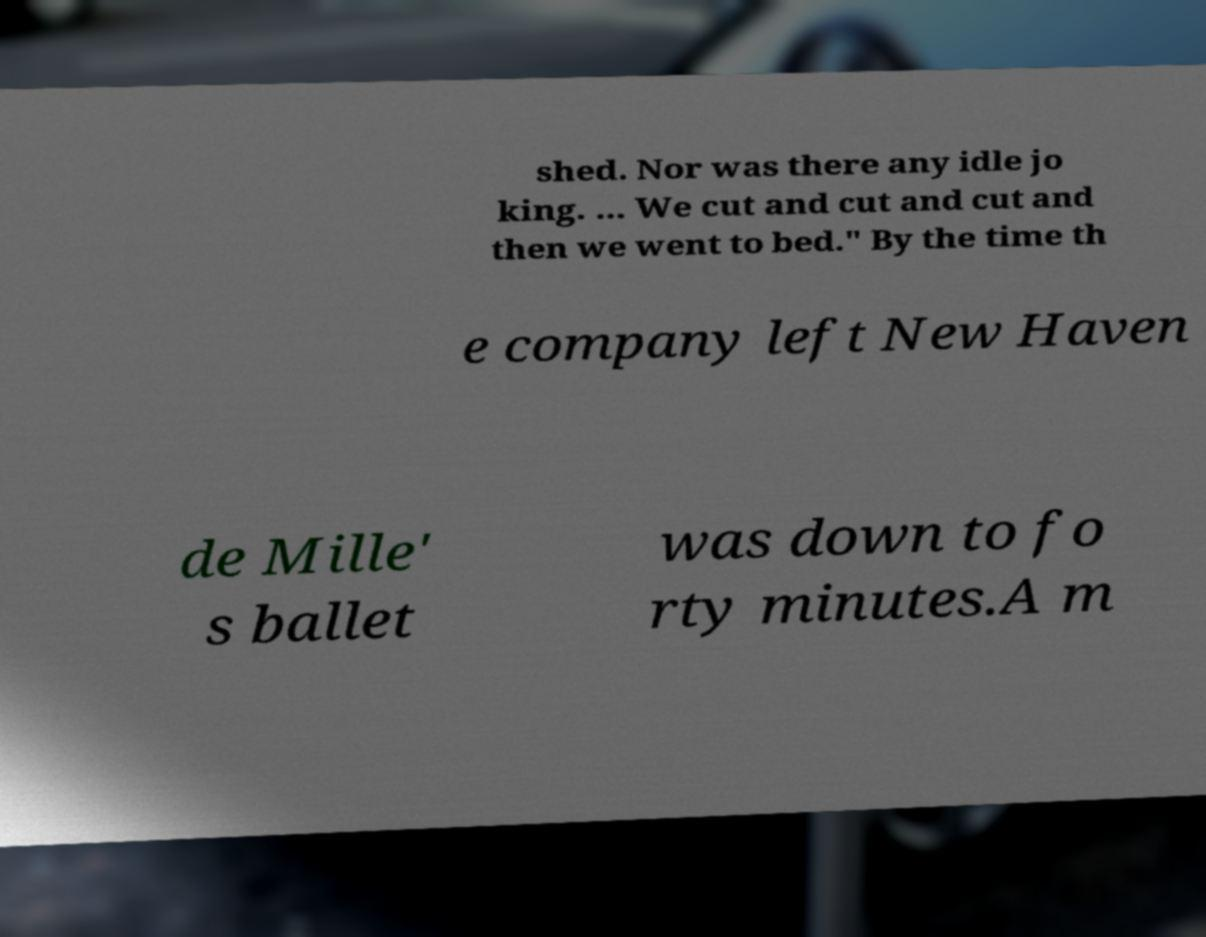Please read and relay the text visible in this image. What does it say? shed. Nor was there any idle jo king. ... We cut and cut and cut and then we went to bed." By the time th e company left New Haven de Mille' s ballet was down to fo rty minutes.A m 